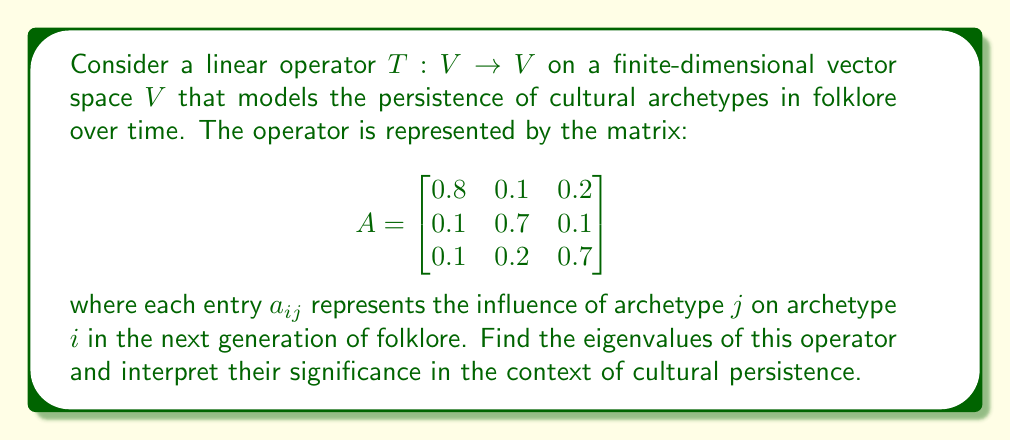Provide a solution to this math problem. To find the eigenvalues of the linear operator $T$, we need to solve the characteristic equation:

$$\det(A - \lambda I) = 0$$

where $I$ is the $3 \times 3$ identity matrix and $\lambda$ represents the eigenvalues.

Step 1: Set up the characteristic equation:

$$\det\begin{pmatrix}
0.8 - \lambda & 0.1 & 0.2 \\
0.1 & 0.7 - \lambda & 0.1 \\
0.1 & 0.2 & 0.7 - \lambda
\end{pmatrix} = 0$$

Step 2: Expand the determinant:

$$(0.8 - \lambda)((0.7 - \lambda)^2 - 0.02) - 0.1(0.1(0.7 - \lambda) - 0.02) + 0.2(0.1(0.7 - \lambda) - 0.01) = 0$$

Step 3: Simplify and rearrange:

$$-\lambda^3 + 2.2\lambda^2 - 1.51\lambda + 0.322 = 0$$

Step 4: Solve the cubic equation. This can be done using various methods, such as the cubic formula or numerical methods. Using a computer algebra system, we find the roots:

$$\lambda_1 \approx 1, \lambda_2 \approx 0.7, \lambda_3 \approx 0.5$$

Interpretation:
1. The largest eigenvalue $\lambda_1 \approx 1$ suggests that there is a dominant cultural archetype that persists strongly over time.
2. The second eigenvalue $\lambda_2 \approx 0.7$ indicates a moderately persistent archetype.
3. The third eigenvalue $\lambda_3 \approx 0.5$ represents a less persistent archetype that may fade more quickly over generations.

These eigenvalues provide insight into the long-term behavior of cultural archetypes in folklore. The closer an eigenvalue is to 1, the more persistent the corresponding archetype is likely to be in the cultural narrative.
Answer: The eigenvalues of the linear operator are approximately:
$$\lambda_1 \approx 1, \lambda_2 \approx 0.7, \lambda_3 \approx 0.5$$
These values indicate varying degrees of persistence for different cultural archetypes in folklore over time. 